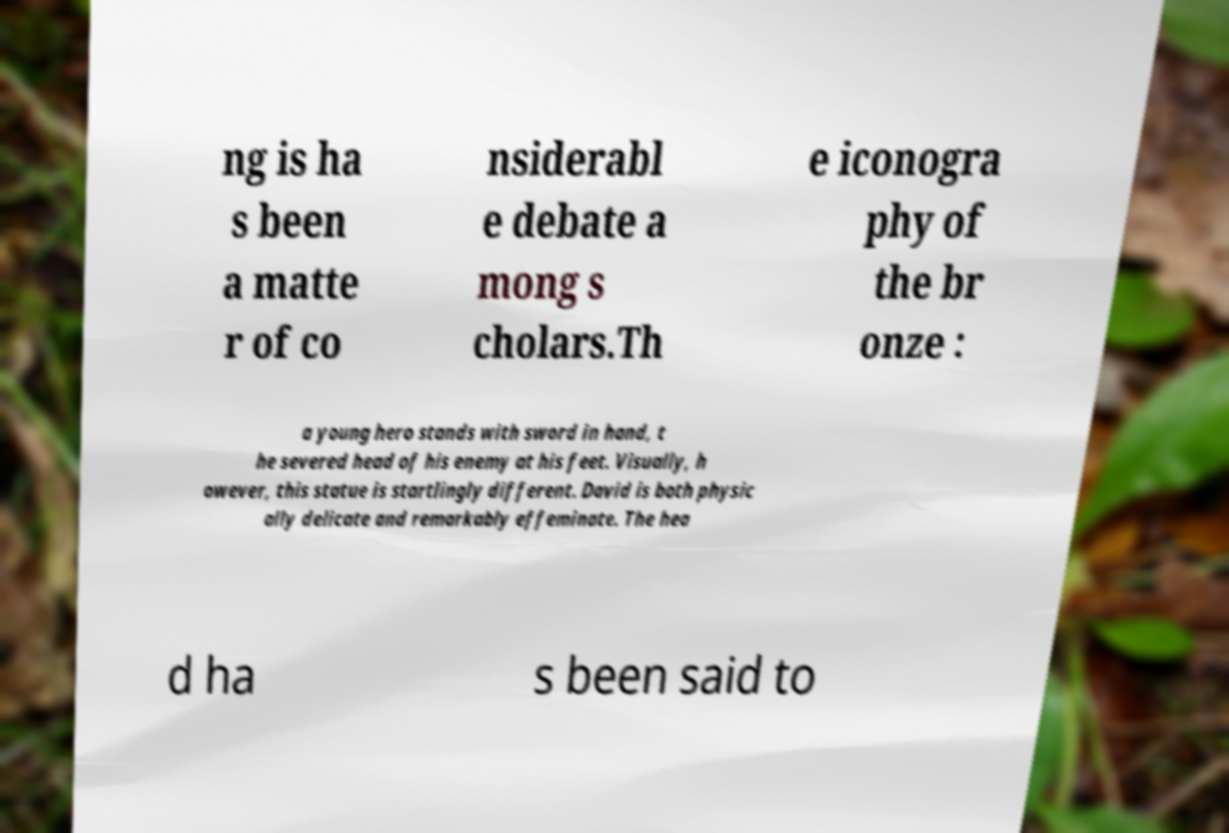Can you accurately transcribe the text from the provided image for me? ng is ha s been a matte r of co nsiderabl e debate a mong s cholars.Th e iconogra phy of the br onze : a young hero stands with sword in hand, t he severed head of his enemy at his feet. Visually, h owever, this statue is startlingly different. David is both physic ally delicate and remarkably effeminate. The hea d ha s been said to 